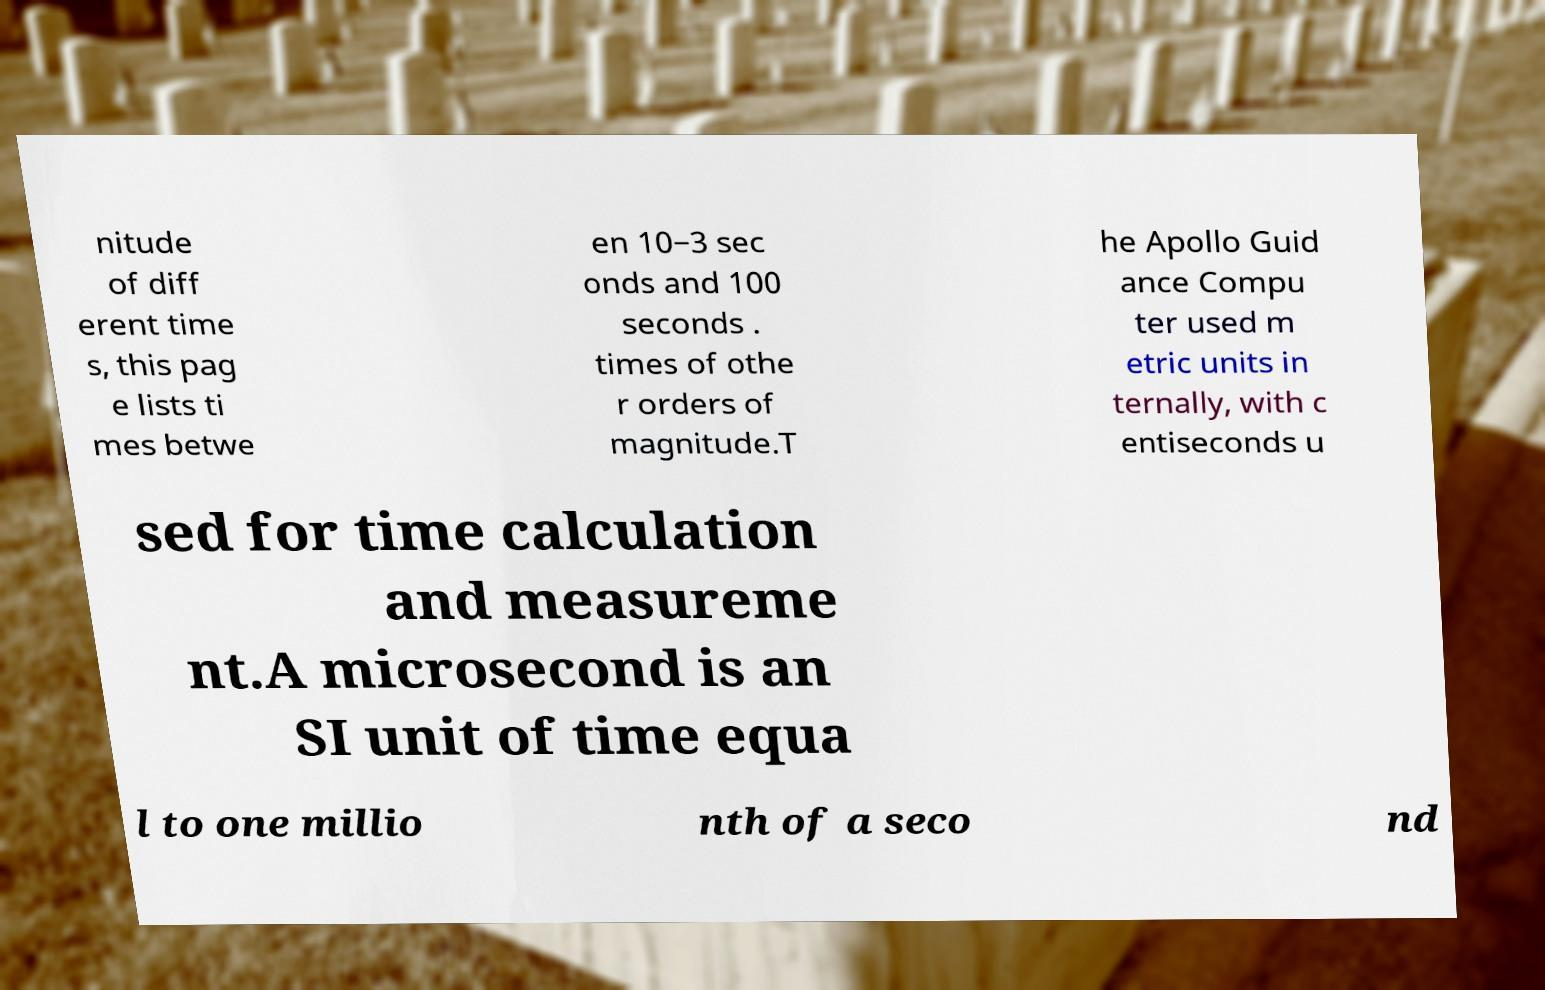Please identify and transcribe the text found in this image. nitude of diff erent time s, this pag e lists ti mes betwe en 10−3 sec onds and 100 seconds . times of othe r orders of magnitude.T he Apollo Guid ance Compu ter used m etric units in ternally, with c entiseconds u sed for time calculation and measureme nt.A microsecond is an SI unit of time equa l to one millio nth of a seco nd 